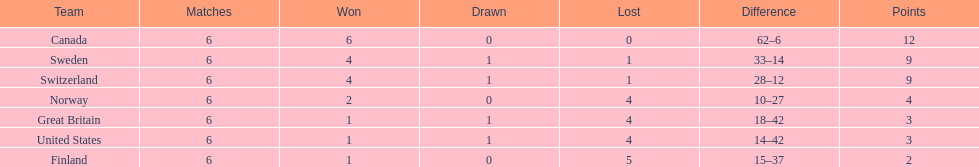How many teams won 6 matches? 1. 